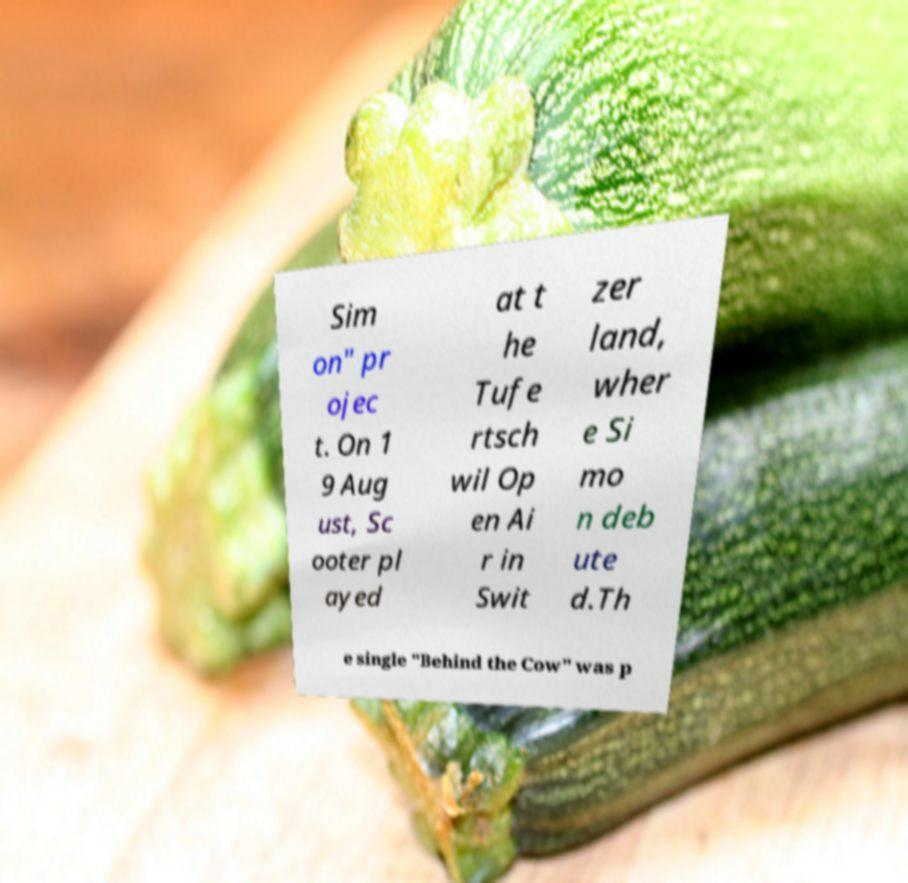Please read and relay the text visible in this image. What does it say? Sim on" pr ojec t. On 1 9 Aug ust, Sc ooter pl ayed at t he Tufe rtsch wil Op en Ai r in Swit zer land, wher e Si mo n deb ute d.Th e single "Behind the Cow" was p 